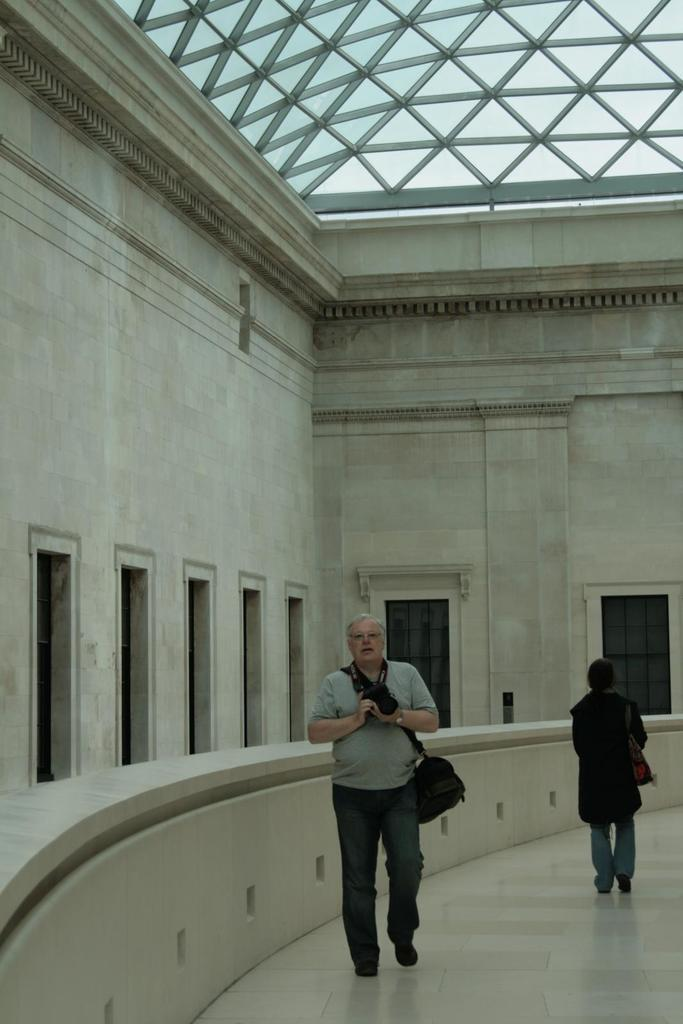What is the main structure in the image? There is a building in the image. What feature can be seen on the building? The building has windows. Can you describe the activity of the people in the image? There are two persons walking in the image. What type of suit is the person wearing in the image? There is no person wearing a suit in the image; the two persons walking are not wearing suits. What time of day is it in the image? The time of day cannot be determined from the image alone, as there are no specific clues or indicators of time. 